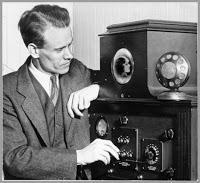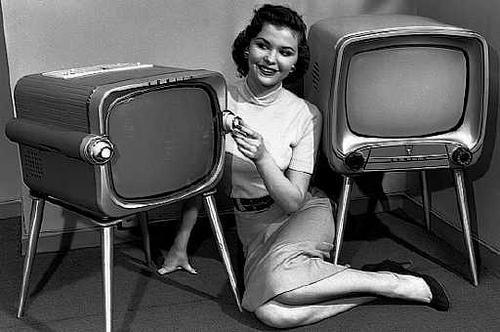The first image is the image on the left, the second image is the image on the right. Evaluate the accuracy of this statement regarding the images: "One of the images has no human.". Is it true? Answer yes or no. No. The first image is the image on the left, the second image is the image on the right. For the images shown, is this caption "The right image contains one flat screen television that is turned off." true? Answer yes or no. No. 